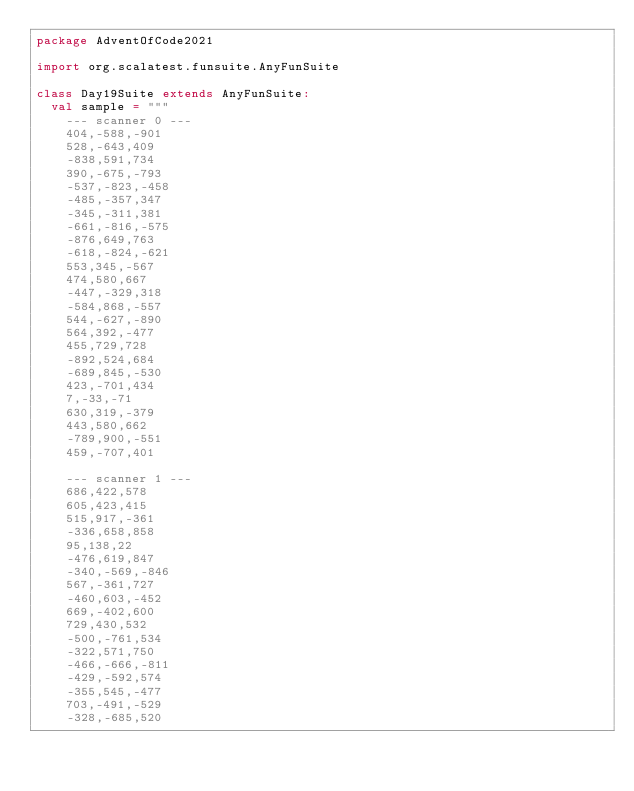Convert code to text. <code><loc_0><loc_0><loc_500><loc_500><_Scala_>package AdventOfCode2021

import org.scalatest.funsuite.AnyFunSuite

class Day19Suite extends AnyFunSuite:
  val sample = """
    --- scanner 0 ---
    404,-588,-901
    528,-643,409
    -838,591,734
    390,-675,-793
    -537,-823,-458
    -485,-357,347
    -345,-311,381
    -661,-816,-575
    -876,649,763
    -618,-824,-621
    553,345,-567
    474,580,667
    -447,-329,318
    -584,868,-557
    544,-627,-890
    564,392,-477
    455,729,728
    -892,524,684
    -689,845,-530
    423,-701,434
    7,-33,-71
    630,319,-379
    443,580,662
    -789,900,-551
    459,-707,401

    --- scanner 1 ---
    686,422,578
    605,423,415
    515,917,-361
    -336,658,858
    95,138,22
    -476,619,847
    -340,-569,-846
    567,-361,727
    -460,603,-452
    669,-402,600
    729,430,532
    -500,-761,534
    -322,571,750
    -466,-666,-811
    -429,-592,574
    -355,545,-477
    703,-491,-529
    -328,-685,520</code> 